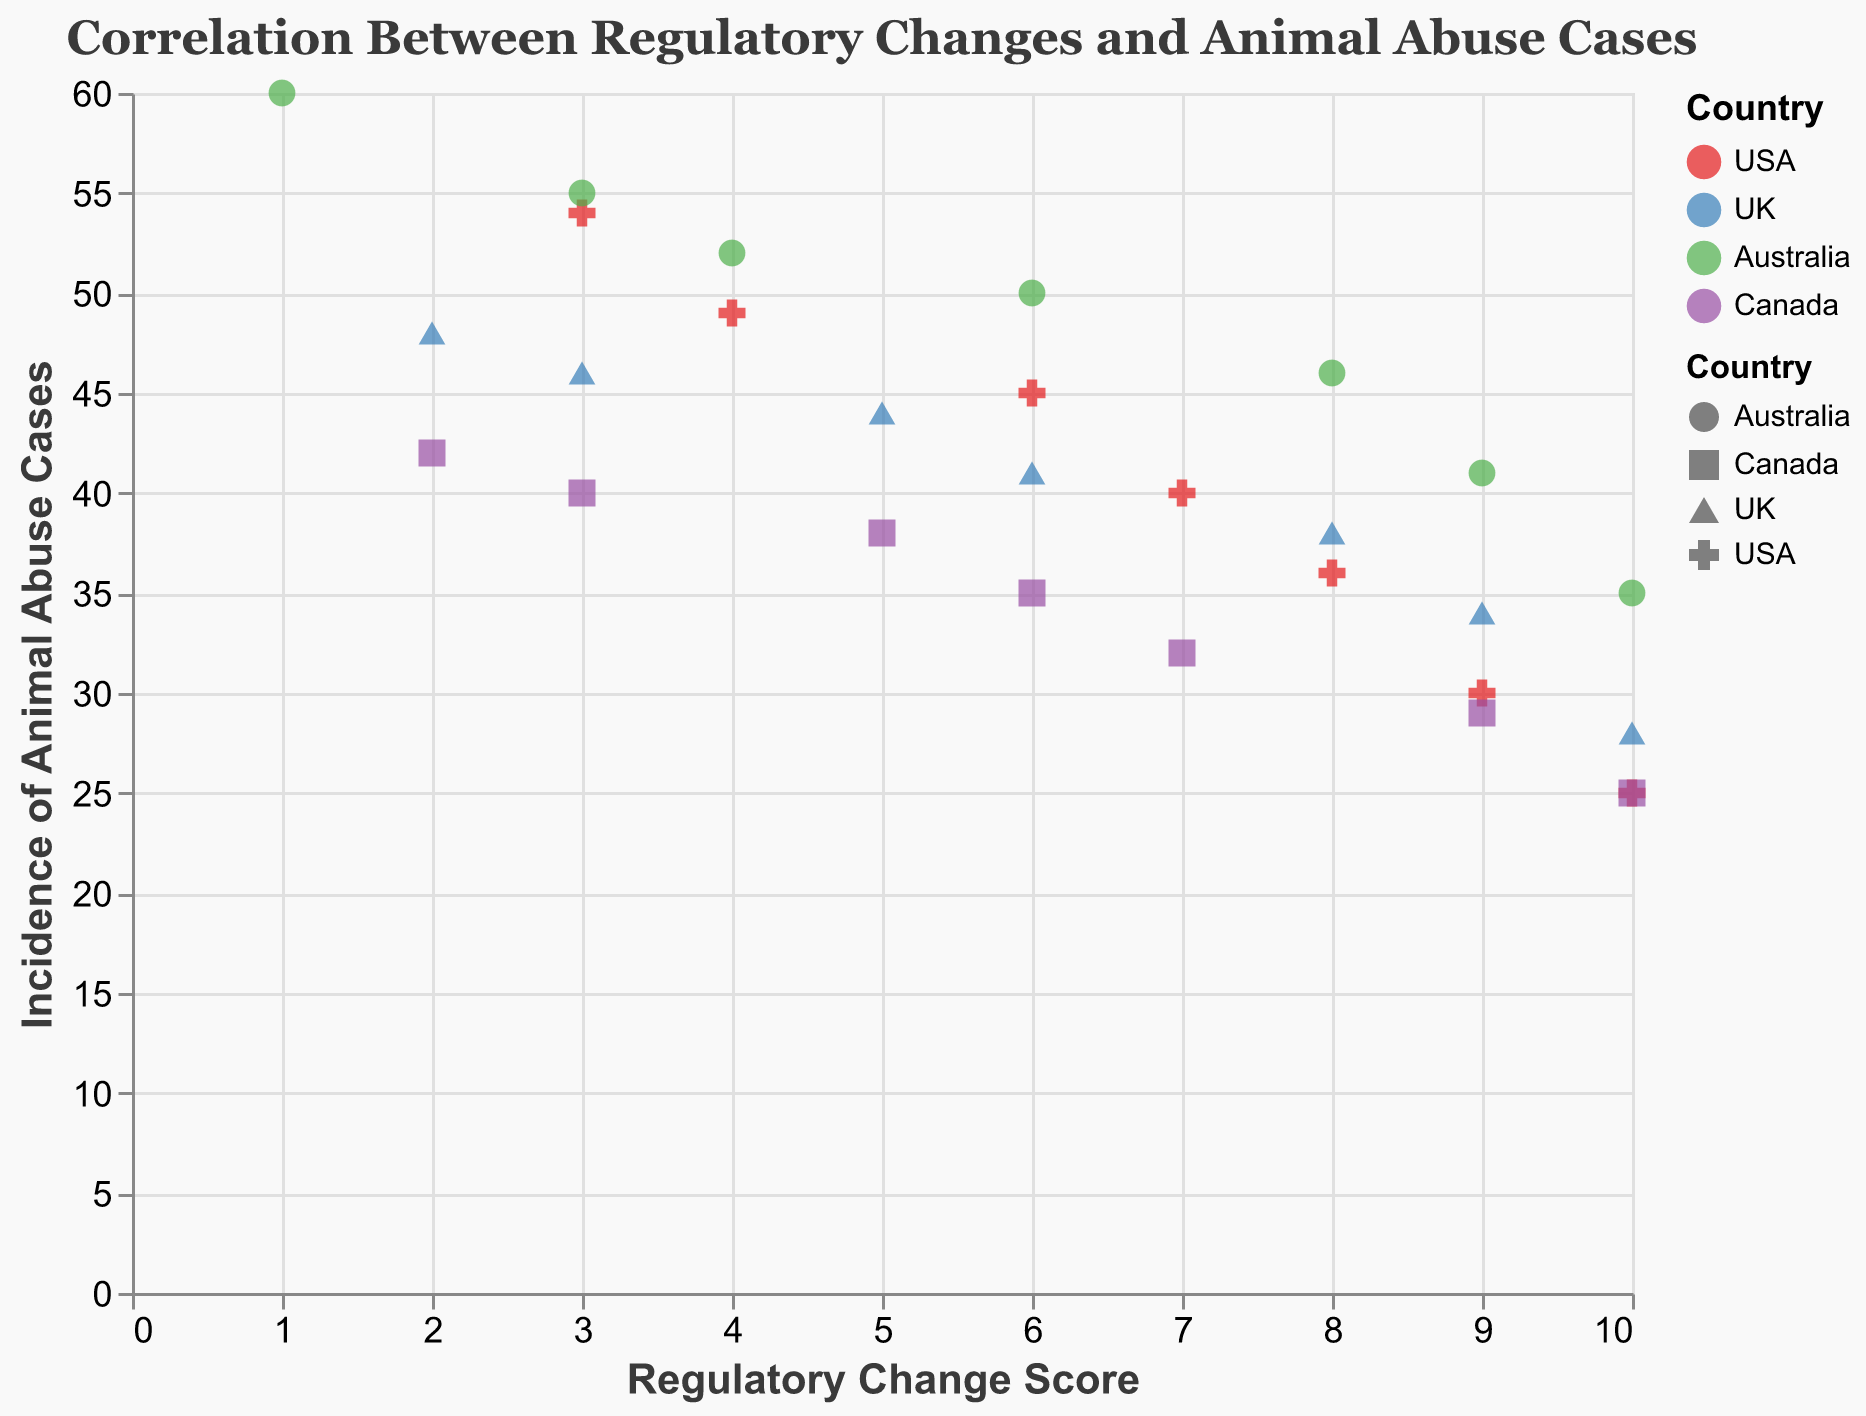What is the title of the figure? The title is displayed at the top of the figure and reads "Correlation Between Regulatory Changes and Animal Abuse Cases".
Answer: "Correlation Between Regulatory Changes and Animal Abuse Cases" What do the axes represent? The x-axis represents the "Regulatory Change Score" and the y-axis represents the "Incidence of Animal Abuse Cases". These are indicated by the axis titles located near the respective axes.
Answer: The x-axis represents the "Regulatory Change Score" and the y-axis represents the "Incidence of Animal Abuse Cases" How many countries' data are represented in the plot? The legend indicates that there are data points for four countries: USA, UK, Australia, and Canada.
Answer: 4 Which country had the highest incidence of animal abuse cases in 2010? Identify the data points for the year 2010 for each country and find the one with the highest y-value. Australia had the highest incidence with a value of 60.
Answer: Australia What is the trend of animal abuse cases as the regulatory change score increases for the USA? The trend line for USA indicates that as the regulatory change score increases, the incidence of animal abuse cases decreases.
Answer: Decreases Compare the incidence of animal abuse cases between Australia and UK in 2014. Locate the points for both Australia and UK in 2014 and compare their y-values. Australia has 46 cases, and the UK has 38 cases. Australia has more cases.
Answer: Australia has more cases Which country shows the steepest decline in animal abuse cases with respect to regulatory changes? Assess the slope of the trend lines for each country. The steeper the line, the greater the rate of decline. The trend line for Australia appears to be the steepest, indicating the sharpest decline.
Answer: Australia Calculate the average regulatory change score for the UK between 2010 and 2016. Identify the regulatory change scores for the UK from 2010 to 2016: 2, 3, 5, 6, 8, 9, 10. Sum these values (2 + 3 + 5 + 6 + 8 + 9 + 10 = 43) and divide by the number of years (7). The average score is 43/7 ≈ 6.14.
Answer: 6.14 Which country had the fewest animal abuse cases in 2016? Find the data points for the year 2016 and compare the y-values. The country with the lowest y-value (25 cases) is both USA and Canada.
Answer: USA and Canada 